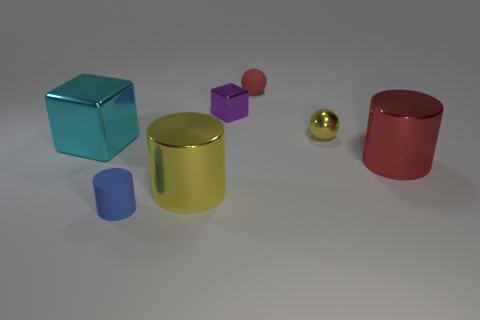Subtract all metal cylinders. How many cylinders are left? 1 Add 2 blue cylinders. How many objects exist? 9 Subtract all cylinders. How many objects are left? 4 Add 6 yellow objects. How many yellow objects are left? 8 Add 3 red cylinders. How many red cylinders exist? 4 Subtract all red balls. How many balls are left? 1 Subtract 1 yellow balls. How many objects are left? 6 Subtract 1 cubes. How many cubes are left? 1 Subtract all red spheres. Subtract all brown blocks. How many spheres are left? 1 Subtract all blue cylinders. How many purple balls are left? 0 